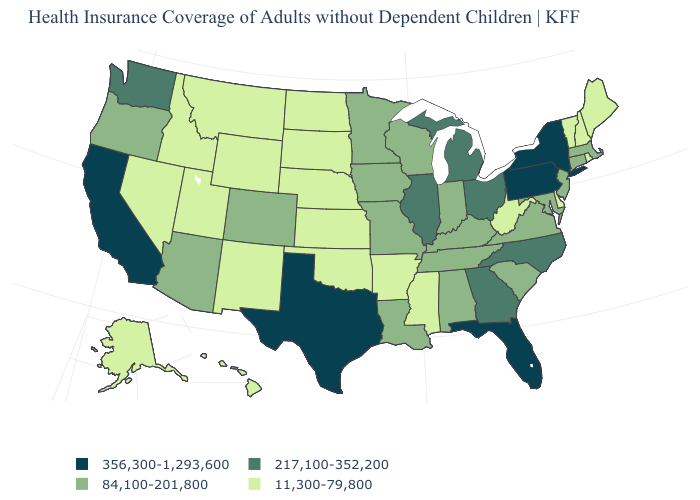Does Illinois have the highest value in the MidWest?
Answer briefly. Yes. Does Montana have the lowest value in the West?
Answer briefly. Yes. What is the value of Kansas?
Keep it brief. 11,300-79,800. Which states have the lowest value in the MidWest?
Be succinct. Kansas, Nebraska, North Dakota, South Dakota. Name the states that have a value in the range 356,300-1,293,600?
Write a very short answer. California, Florida, New York, Pennsylvania, Texas. Name the states that have a value in the range 84,100-201,800?
Quick response, please. Alabama, Arizona, Colorado, Connecticut, Indiana, Iowa, Kentucky, Louisiana, Maryland, Massachusetts, Minnesota, Missouri, New Jersey, Oregon, South Carolina, Tennessee, Virginia, Wisconsin. What is the lowest value in states that border New Hampshire?
Short answer required. 11,300-79,800. What is the value of Alabama?
Quick response, please. 84,100-201,800. What is the lowest value in the USA?
Keep it brief. 11,300-79,800. Which states have the lowest value in the USA?
Write a very short answer. Alaska, Arkansas, Delaware, Hawaii, Idaho, Kansas, Maine, Mississippi, Montana, Nebraska, Nevada, New Hampshire, New Mexico, North Dakota, Oklahoma, Rhode Island, South Dakota, Utah, Vermont, West Virginia, Wyoming. Which states have the lowest value in the West?
Concise answer only. Alaska, Hawaii, Idaho, Montana, Nevada, New Mexico, Utah, Wyoming. What is the value of Florida?
Keep it brief. 356,300-1,293,600. What is the value of Kansas?
Keep it brief. 11,300-79,800. What is the highest value in the West ?
Short answer required. 356,300-1,293,600. What is the value of Indiana?
Quick response, please. 84,100-201,800. 